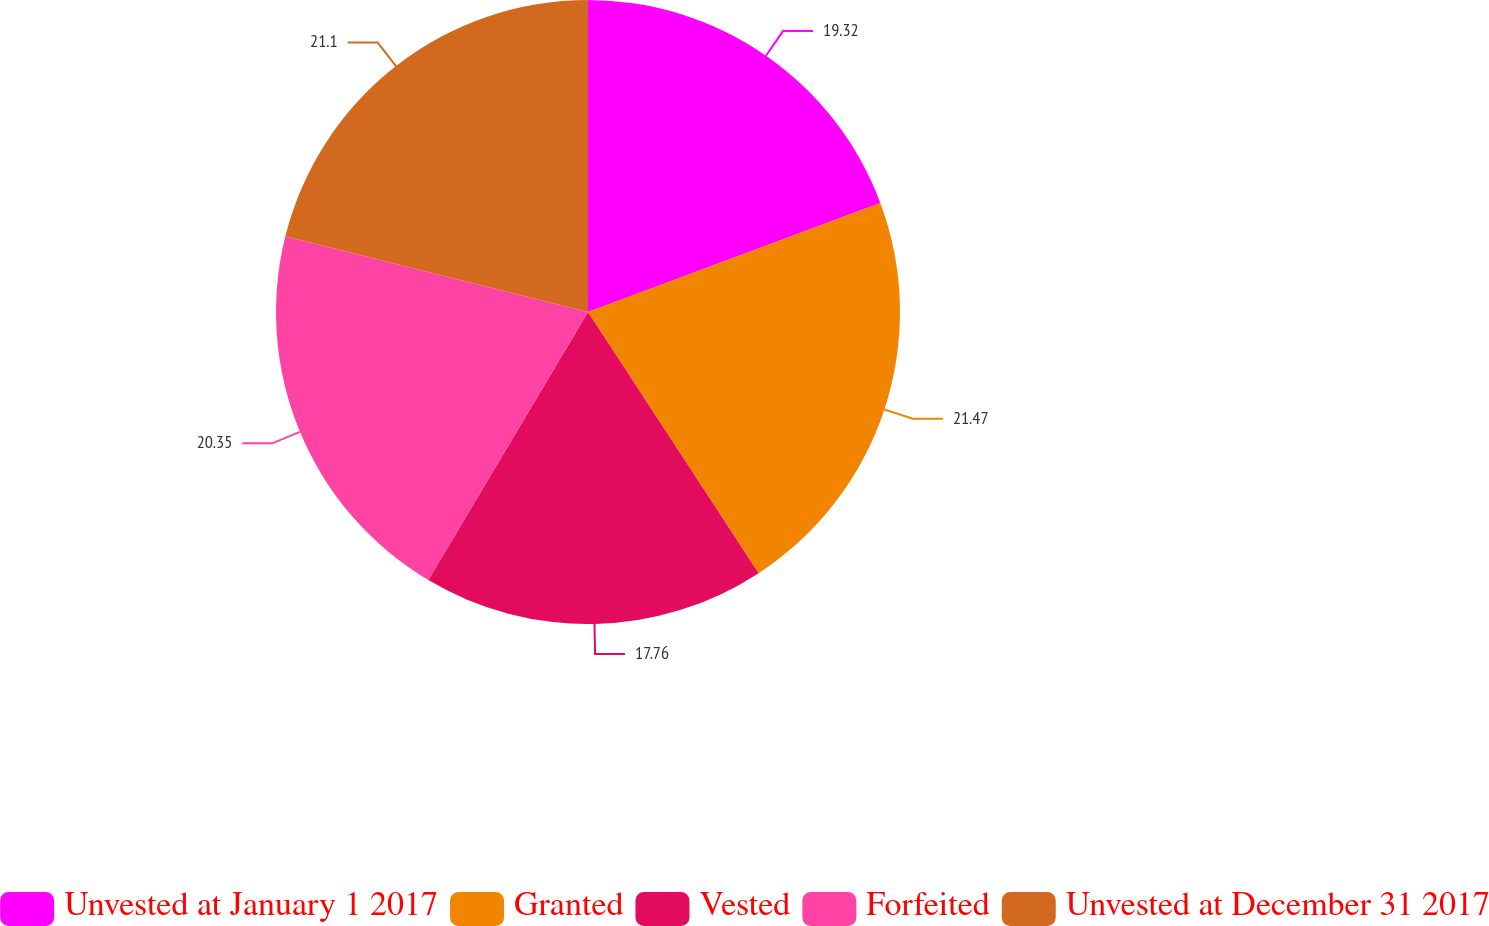<chart> <loc_0><loc_0><loc_500><loc_500><pie_chart><fcel>Unvested at January 1 2017<fcel>Granted<fcel>Vested<fcel>Forfeited<fcel>Unvested at December 31 2017<nl><fcel>19.32%<fcel>21.47%<fcel>17.76%<fcel>20.35%<fcel>21.1%<nl></chart> 